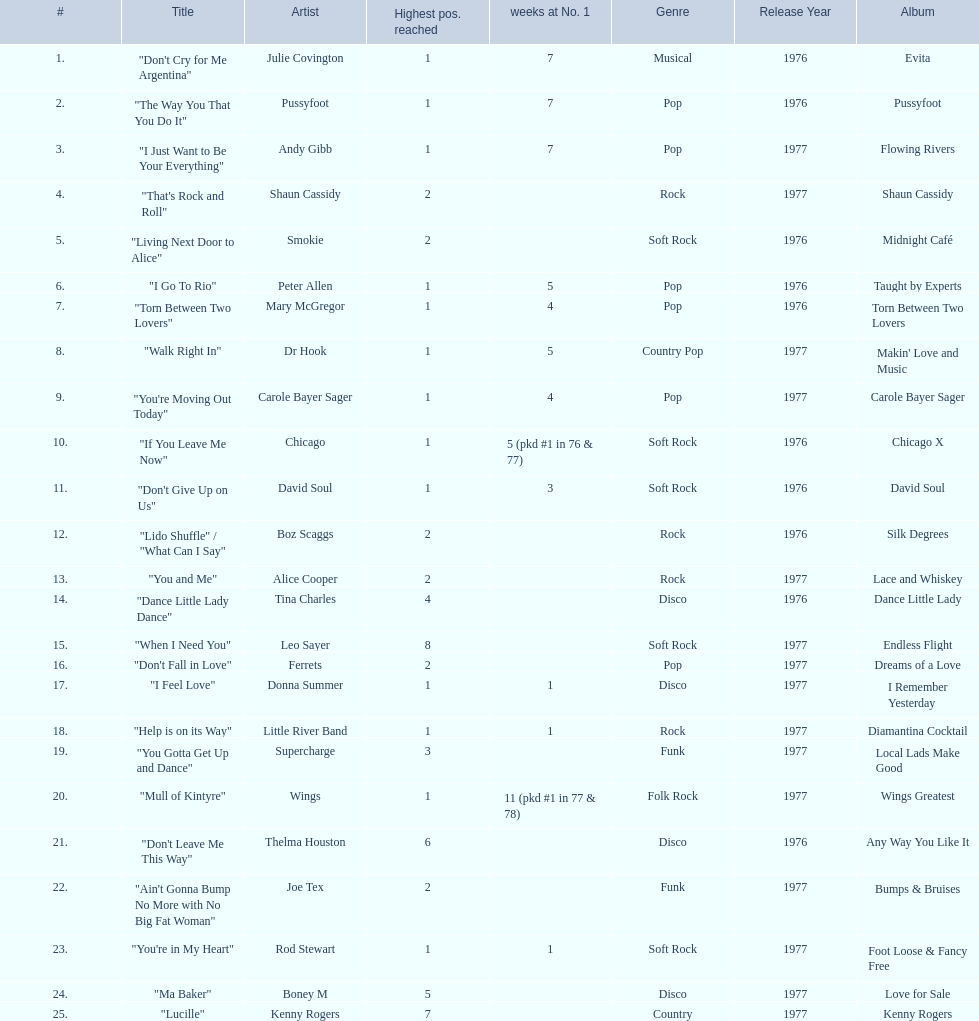How long is the longest amount of time spent at number 1? 11 (pkd #1 in 77 & 78). What song spent 11 weeks at number 1? "Mull of Kintyre". What band had a number 1 hit with this song? Wings. 